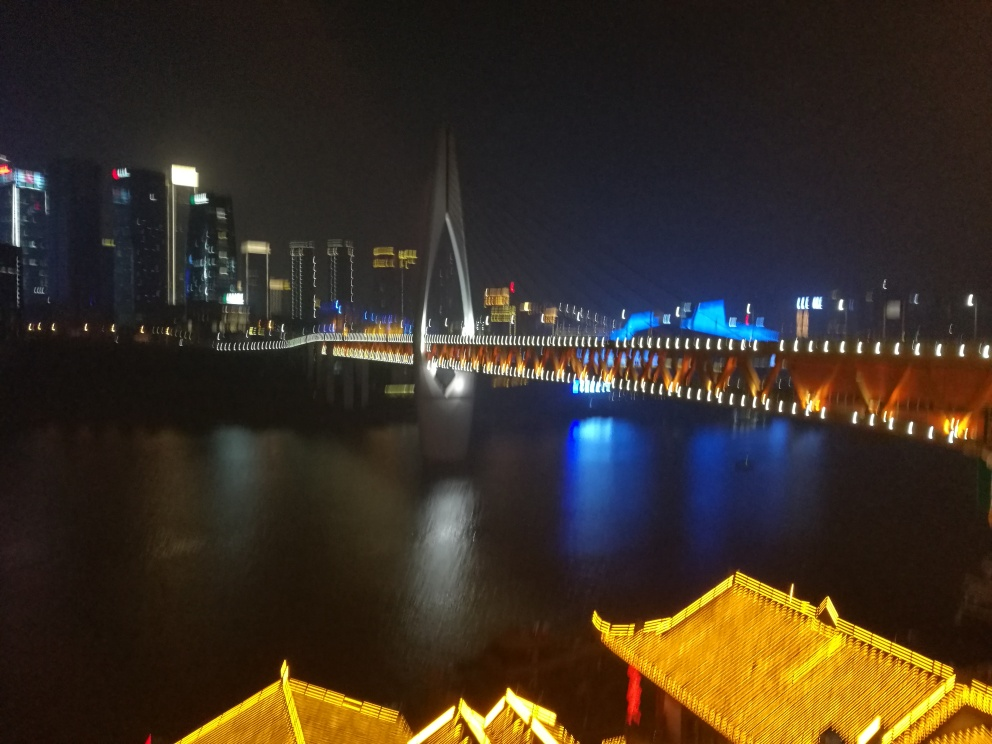What might be the location of this image, based on the architecture and lighting? While the specific location cannot be determined without additional context, the architecture and decorative lighting suggest that this could be a scene from an urban area with a mix of modern cityscapes, potentially in a region that values aesthetic lighting on bridges and buildings. Such scenes are commonly found in East Asian cities. 